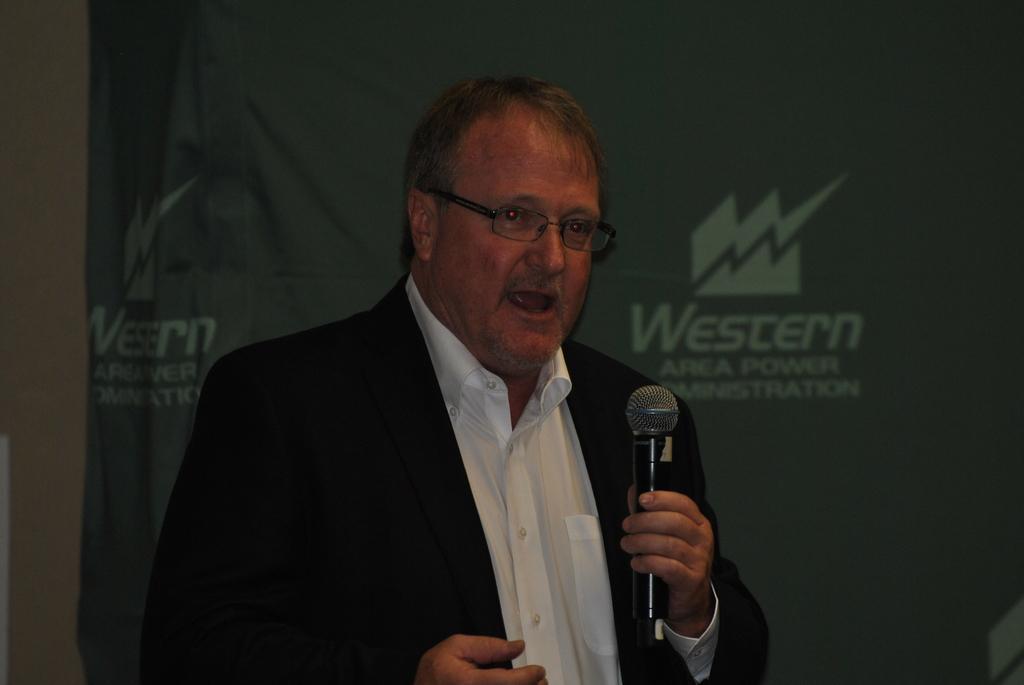Describe this image in one or two sentences. In this image I can see a man. I can also see he is wearing a specs and holding a mic. 